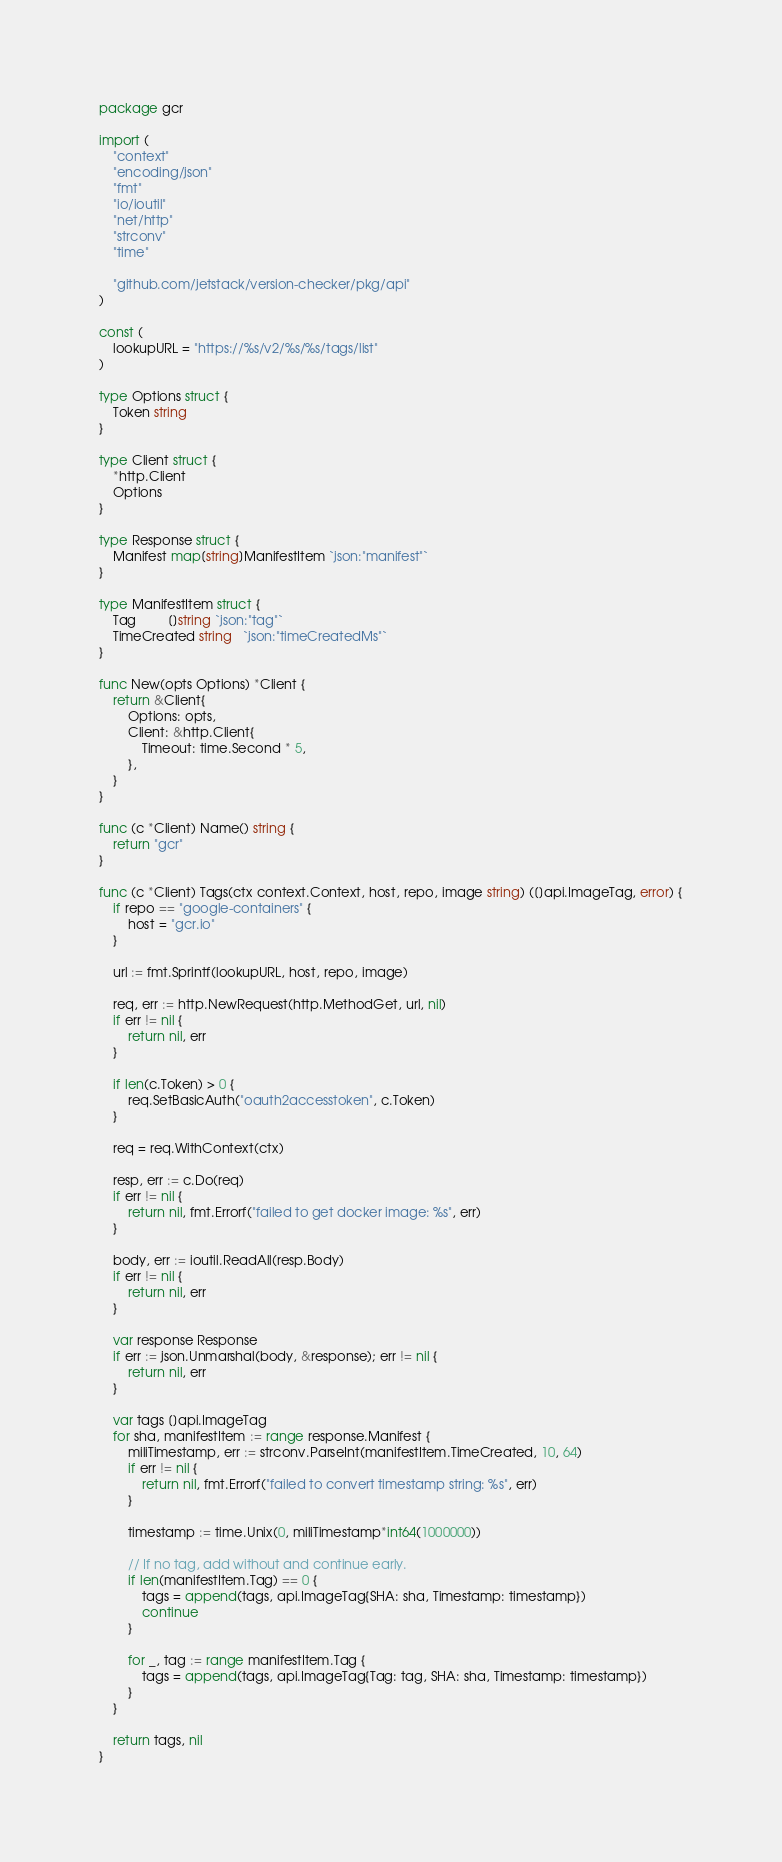Convert code to text. <code><loc_0><loc_0><loc_500><loc_500><_Go_>package gcr

import (
	"context"
	"encoding/json"
	"fmt"
	"io/ioutil"
	"net/http"
	"strconv"
	"time"

	"github.com/jetstack/version-checker/pkg/api"
)

const (
	lookupURL = "https://%s/v2/%s/%s/tags/list"
)

type Options struct {
	Token string
}

type Client struct {
	*http.Client
	Options
}

type Response struct {
	Manifest map[string]ManifestItem `json:"manifest"`
}

type ManifestItem struct {
	Tag         []string `json:"tag"`
	TimeCreated string   `json:"timeCreatedMs"`
}

func New(opts Options) *Client {
	return &Client{
		Options: opts,
		Client: &http.Client{
			Timeout: time.Second * 5,
		},
	}
}

func (c *Client) Name() string {
	return "gcr"
}

func (c *Client) Tags(ctx context.Context, host, repo, image string) ([]api.ImageTag, error) {
	if repo == "google-containers" {
		host = "gcr.io"
	}

	url := fmt.Sprintf(lookupURL, host, repo, image)

	req, err := http.NewRequest(http.MethodGet, url, nil)
	if err != nil {
		return nil, err
	}

	if len(c.Token) > 0 {
		req.SetBasicAuth("oauth2accesstoken", c.Token)
	}

	req = req.WithContext(ctx)

	resp, err := c.Do(req)
	if err != nil {
		return nil, fmt.Errorf("failed to get docker image: %s", err)
	}

	body, err := ioutil.ReadAll(resp.Body)
	if err != nil {
		return nil, err
	}

	var response Response
	if err := json.Unmarshal(body, &response); err != nil {
		return nil, err
	}

	var tags []api.ImageTag
	for sha, manifestItem := range response.Manifest {
		miliTimestamp, err := strconv.ParseInt(manifestItem.TimeCreated, 10, 64)
		if err != nil {
			return nil, fmt.Errorf("failed to convert timestamp string: %s", err)
		}

		timestamp := time.Unix(0, miliTimestamp*int64(1000000))

		// If no tag, add without and continue early.
		if len(manifestItem.Tag) == 0 {
			tags = append(tags, api.ImageTag{SHA: sha, Timestamp: timestamp})
			continue
		}

		for _, tag := range manifestItem.Tag {
			tags = append(tags, api.ImageTag{Tag: tag, SHA: sha, Timestamp: timestamp})
		}
	}

	return tags, nil
}
</code> 